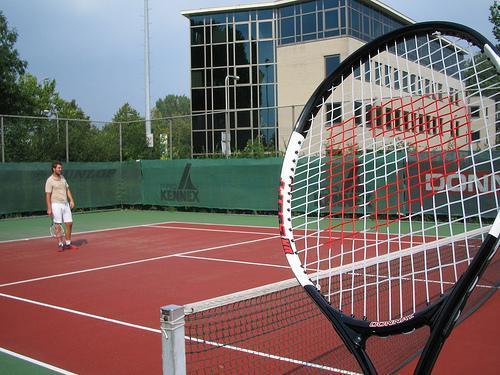How many players are in the tennis court?
Give a very brief answer. 1. 